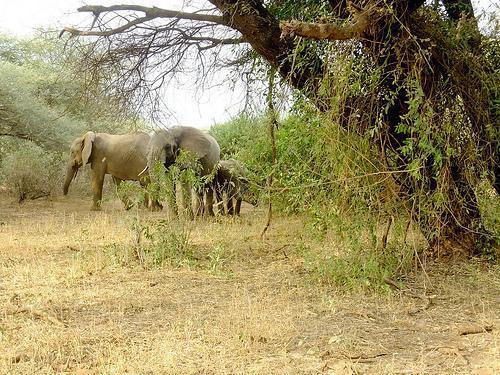How many elephants are there?
Give a very brief answer. 3. 